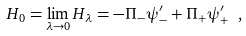<formula> <loc_0><loc_0><loc_500><loc_500>H _ { 0 } = \lim _ { \lambda \rightarrow 0 } H _ { \lambda } = - \Pi _ { - } \psi _ { - } ^ { \prime } + \Pi _ { + } \psi _ { + } ^ { \prime } \ ,</formula> 